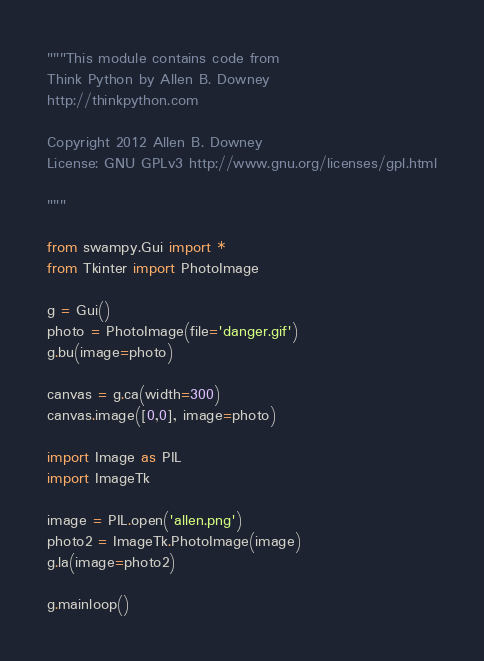Convert code to text. <code><loc_0><loc_0><loc_500><loc_500><_Python_>"""This module contains code from
Think Python by Allen B. Downey
http://thinkpython.com

Copyright 2012 Allen B. Downey
License: GNU GPLv3 http://www.gnu.org/licenses/gpl.html

"""

from swampy.Gui import *
from Tkinter import PhotoImage

g = Gui()
photo = PhotoImage(file='danger.gif')
g.bu(image=photo)

canvas = g.ca(width=300)
canvas.image([0,0], image=photo)

import Image as PIL
import ImageTk

image = PIL.open('allen.png')
photo2 = ImageTk.PhotoImage(image)
g.la(image=photo2)

g.mainloop()
</code> 